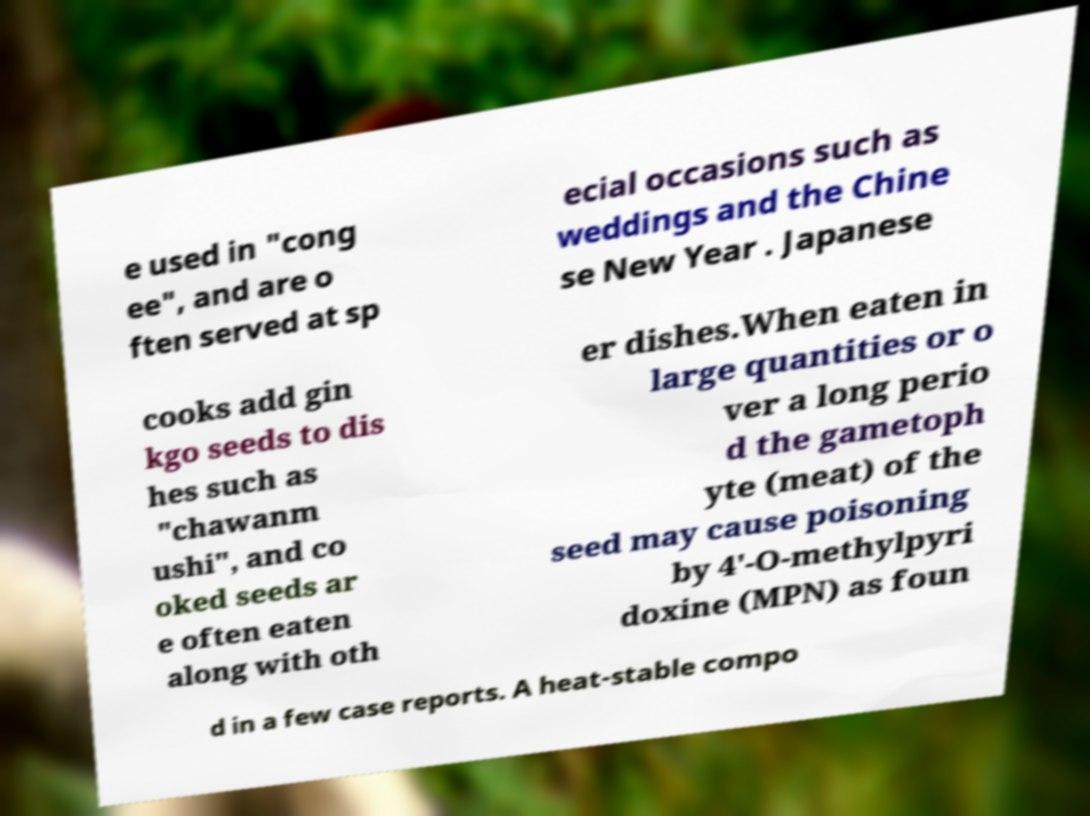Please read and relay the text visible in this image. What does it say? e used in "cong ee", and are o ften served at sp ecial occasions such as weddings and the Chine se New Year . Japanese cooks add gin kgo seeds to dis hes such as "chawanm ushi", and co oked seeds ar e often eaten along with oth er dishes.When eaten in large quantities or o ver a long perio d the gametoph yte (meat) of the seed may cause poisoning by 4'-O-methylpyri doxine (MPN) as foun d in a few case reports. A heat-stable compo 